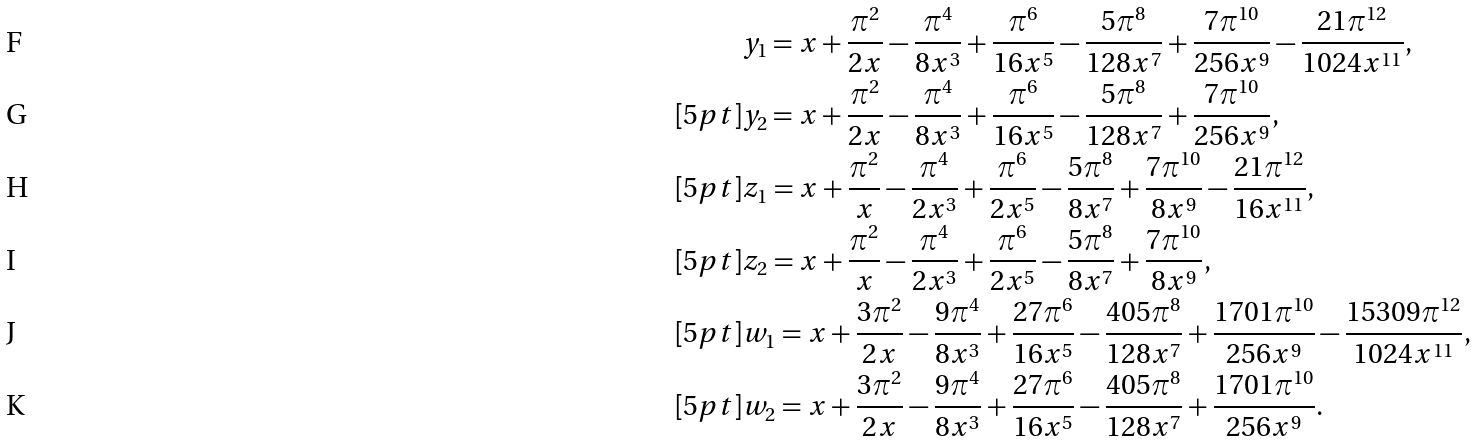Convert formula to latex. <formula><loc_0><loc_0><loc_500><loc_500>& y _ { 1 } = x + \frac { \pi ^ { 2 } } { 2 x } - \frac { \pi ^ { 4 } } { 8 x ^ { 3 } } + \frac { \pi ^ { 6 } } { 1 6 x ^ { 5 } } - \frac { 5 \pi ^ { 8 } } { 1 2 8 x ^ { 7 } } + \frac { 7 \pi ^ { 1 0 } } { 2 5 6 x ^ { 9 } } - \frac { 2 1 \pi ^ { 1 2 } } { 1 0 2 4 x ^ { 1 1 } } , \\ [ 5 p t ] & y _ { 2 } = x + \frac { \pi ^ { 2 } } { 2 x } - \frac { \pi ^ { 4 } } { 8 x ^ { 3 } } + \frac { \pi ^ { 6 } } { 1 6 x ^ { 5 } } - \frac { 5 \pi ^ { 8 } } { 1 2 8 x ^ { 7 } } + \frac { 7 \pi ^ { 1 0 } } { 2 5 6 x ^ { 9 } } , \\ [ 5 p t ] & z _ { 1 } = x + \frac { \pi ^ { 2 } } { x } - \frac { \pi ^ { 4 } } { 2 x ^ { 3 } } + \frac { \pi ^ { 6 } } { 2 x ^ { 5 } } - \frac { 5 \pi ^ { 8 } } { 8 x ^ { 7 } } + \frac { 7 \pi ^ { 1 0 } } { 8 x ^ { 9 } } - \frac { 2 1 \pi ^ { 1 2 } } { 1 6 x ^ { 1 1 } } , \\ [ 5 p t ] & z _ { 2 } = x + \frac { \pi ^ { 2 } } { x } - \frac { \pi ^ { 4 } } { 2 x ^ { 3 } } + \frac { \pi ^ { 6 } } { 2 x ^ { 5 } } - \frac { 5 \pi ^ { 8 } } { 8 x ^ { 7 } } + \frac { 7 \pi ^ { 1 0 } } { 8 x ^ { 9 } } , \\ [ 5 p t ] & w _ { 1 } = x + \frac { 3 \pi ^ { 2 } } { 2 x } - \frac { 9 \pi ^ { 4 } } { 8 x ^ { 3 } } + \frac { 2 7 \pi ^ { 6 } } { 1 6 x ^ { 5 } } - \frac { 4 0 5 \pi ^ { 8 } } { 1 2 8 x ^ { 7 } } + \frac { 1 7 0 1 \pi ^ { 1 0 } } { 2 5 6 x ^ { 9 } } - \frac { 1 5 3 0 9 \pi ^ { 1 2 } } { 1 0 2 4 x ^ { 1 1 } } , \\ [ 5 p t ] & w _ { 2 } = x + \frac { 3 \pi ^ { 2 } } { 2 x } - \frac { 9 \pi ^ { 4 } } { 8 x ^ { 3 } } + \frac { 2 7 \pi ^ { 6 } } { 1 6 x ^ { 5 } } - \frac { 4 0 5 \pi ^ { 8 } } { 1 2 8 x ^ { 7 } } + \frac { 1 7 0 1 \pi ^ { 1 0 } } { 2 5 6 x ^ { 9 } } .</formula> 